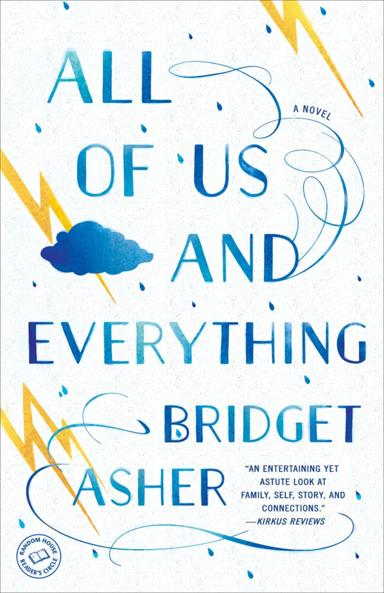What does the visual design of the book cover suggest about the novel’s content? The book cover, with its vibrant blue and yellow colors and swirling designs, suggests themes of chaos and calm, reflecting the stormy and serene episodes in the characters' lives. The cloud imagery hints at the unpredictability and the ever-changing nature of life, themes central to the novel. 